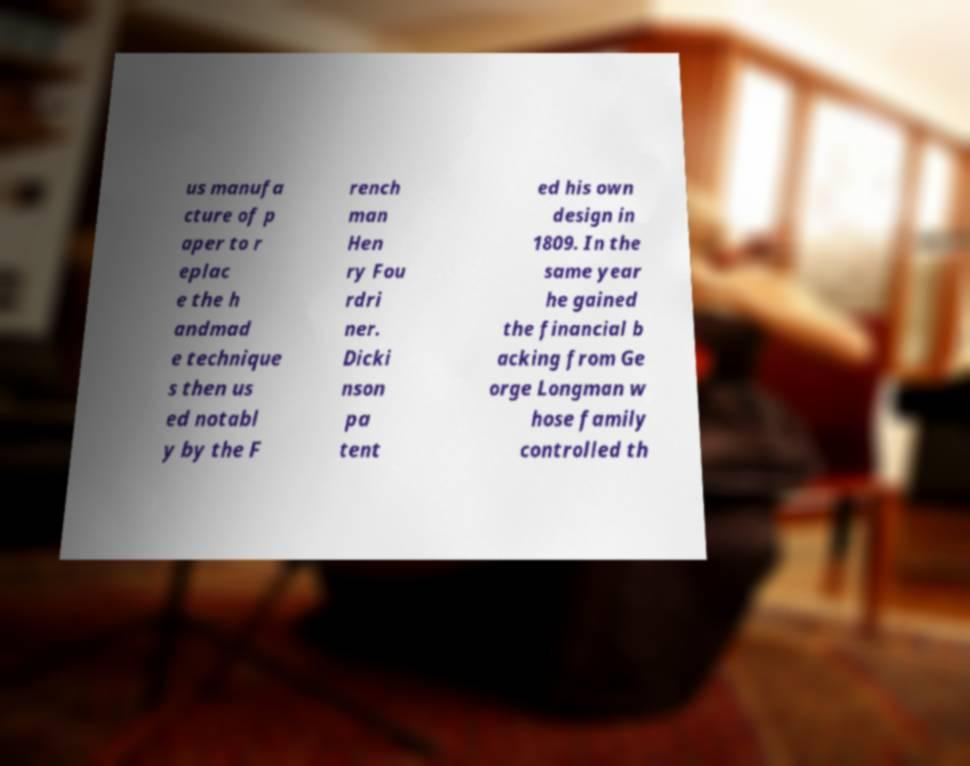There's text embedded in this image that I need extracted. Can you transcribe it verbatim? us manufa cture of p aper to r eplac e the h andmad e technique s then us ed notabl y by the F rench man Hen ry Fou rdri ner. Dicki nson pa tent ed his own design in 1809. In the same year he gained the financial b acking from Ge orge Longman w hose family controlled th 